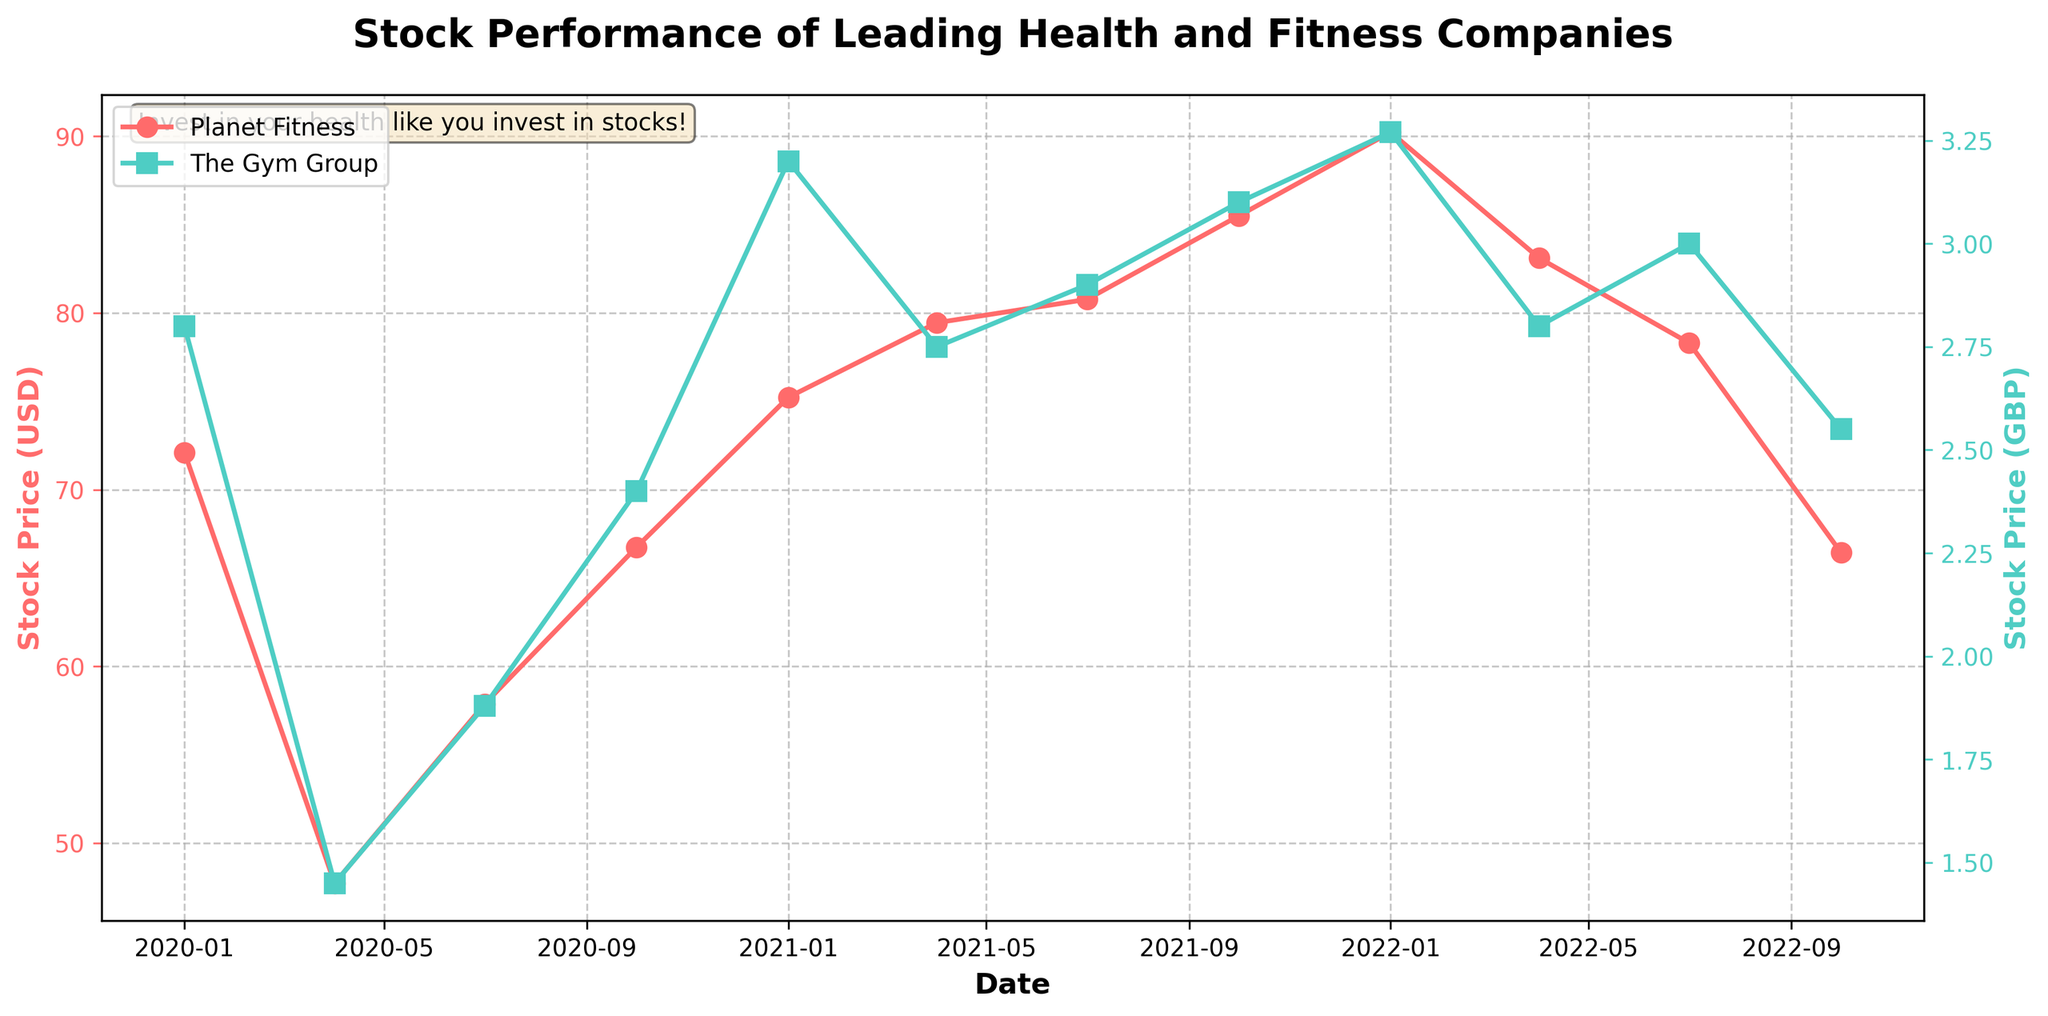What is the title of the plot? The title of the plot is displayed prominently at the top center of the figure, which reads "Stock Performance of Leading Health and Fitness Companies." The visual information directly states this information.
Answer: Stock Performance of Leading Health and Fitness Companies How many companies are displayed in the plot, and which colors represent each? The figure plots two companies: Planet Fitness and The Gym Group. Planet Fitness is depicted in a line plot with red markers ('o'), and The Gym Group is shown with greenish-blue markers ('s'). This can be seen from the legend and the respective line colors.
Answer: Two; Planet Fitness is red, and The Gym Group is greenish-blue Which company's stock price was higher in January 2020? By examining the plot at the point corresponding to January 2020 on the x-axis, it can be observed that Planet Fitness had a higher stock price compared to The Gym Group at this point. The red line for Planet Fitness is situated higher than the greenish-blue line for The Gym Group.
Answer: Planet Fitness What is the difference in Planet Fitness's stock price between January 2021 and April 2021? Locate the data points for January 2021 and April 2021 on the red line for Planet Fitness. The stock price in January 2021 is 75.23 USD and in April 2021 is 79.45 USD. The difference is calculated as 79.45 - 75.23.
Answer: 4.22 USD How did the stock prices of The Gym Group change between January 2022 and October 2022? Observe the greenish-blue line for The Gym Group at the dates corresponding to January 2022 and October 2022. The stock price decreased from 3.27 GBP (January 2022) to 2.55 GBP (October 2022). This shows a decline.
Answer: Decreased Between which two consecutive quarters did Planet Fitness see the highest increase in stock price? By comparing the differences in stock prices at consecutive quarters for Planet Fitness, the most significant rise is seen between January 2022 (90.23 USD) and April 2021 (83.11 USD), which had the highest increase of 7.12 USD.
Answer: January 2022 to April 2021 In which year did both companies experience a general increase in stock prices? By observing the overall trends of the lines for both companies, both Planet Fitness (red line) and The Gym Group (greenish-blue line) generally increased in 2021. Their stock prices in January 2021 were lower than in October 2021.
Answer: 2021 What statement about the relationship between the two companies' stock prices can be made from July 2020? From the plot, in July 2020, Planet Fitness's stock price increases, whereas The Gym Group also shows a slight rise. This shows that both companies had positive stock price changes during this time.
Answer: Both companies' stock prices increased What is the average stock price of Planet Fitness in 2022? Add the stock prices of Planet Fitness for all quarters in 2022 (90.23, 83.11, 78.30, 66.44) and divide by 4 to get the average: (90.23 + 83.11 + 78.30 + 66.44) / 4 = 79.52 USD.
Answer: 79.52 USD 